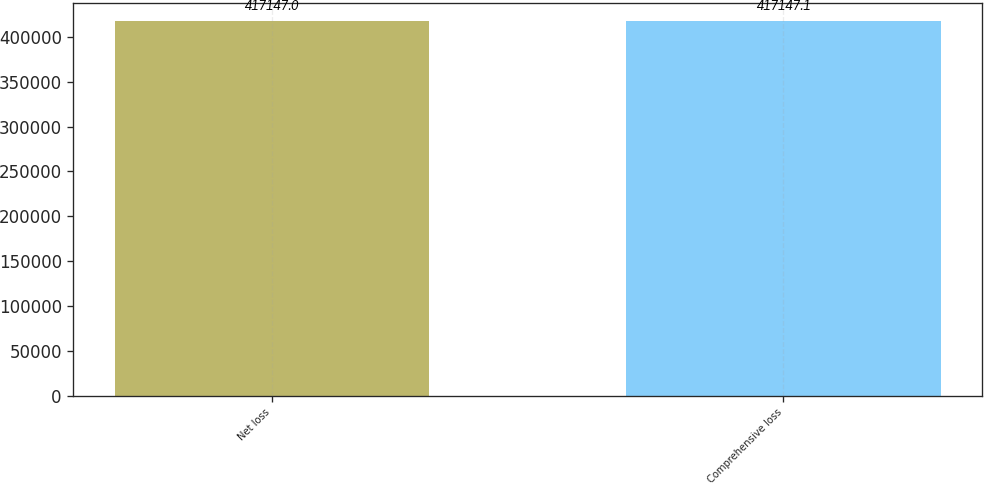<chart> <loc_0><loc_0><loc_500><loc_500><bar_chart><fcel>Net loss<fcel>Comprehensive loss<nl><fcel>417147<fcel>417147<nl></chart> 